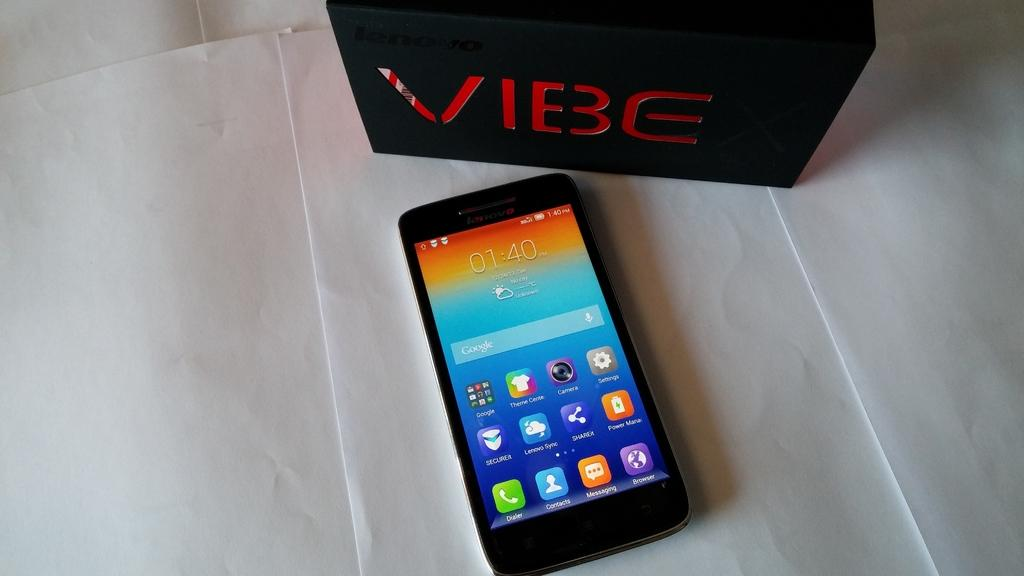<image>
Relay a brief, clear account of the picture shown. the word vibe is on an item next to a phone 